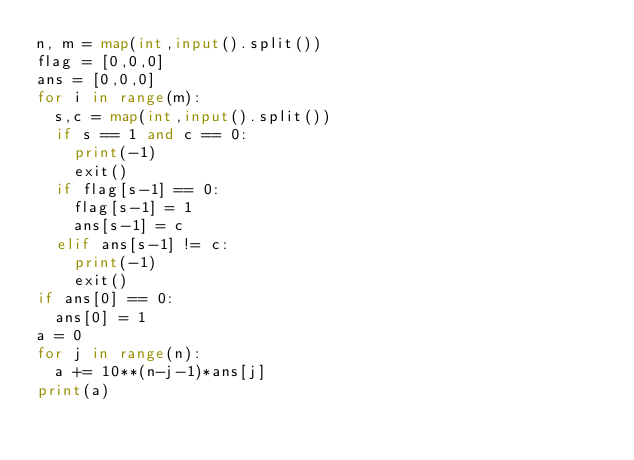<code> <loc_0><loc_0><loc_500><loc_500><_Python_>n, m = map(int,input().split())
flag = [0,0,0]
ans = [0,0,0]
for i in range(m):
  s,c = map(int,input().split())
  if s == 1 and c == 0:
    print(-1)
    exit()
  if flag[s-1] == 0:
    flag[s-1] = 1
    ans[s-1] = c
  elif ans[s-1] != c:
    print(-1)
    exit()
if ans[0] == 0:
  ans[0] = 1
a = 0
for j in range(n):
  a += 10**(n-j-1)*ans[j]
print(a)</code> 